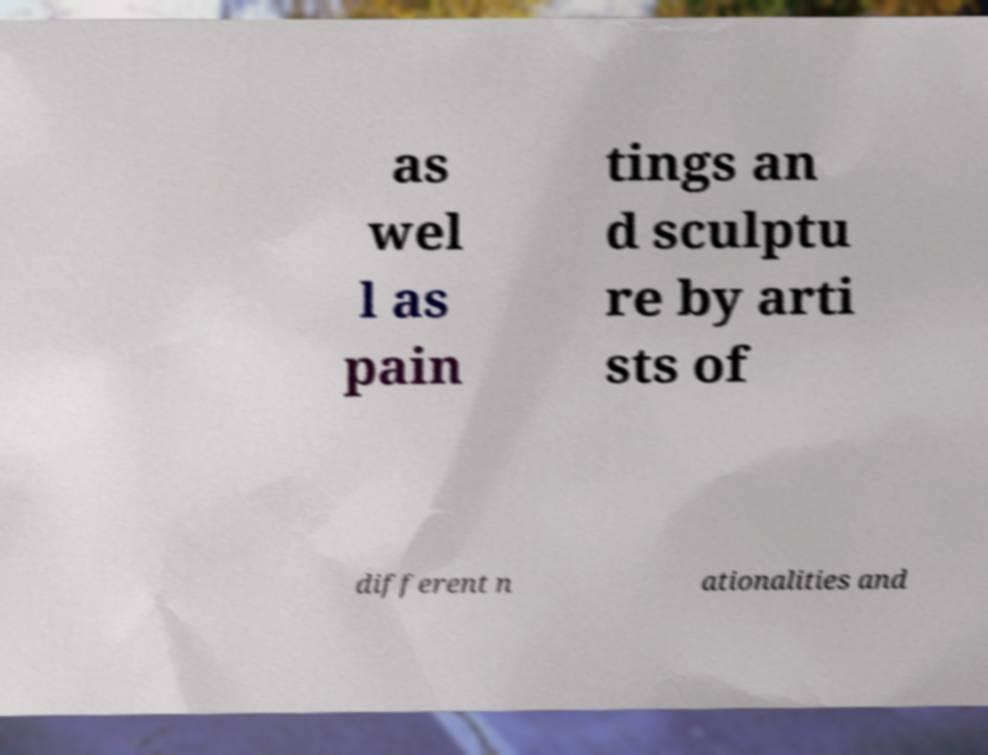Can you accurately transcribe the text from the provided image for me? as wel l as pain tings an d sculptu re by arti sts of different n ationalities and 